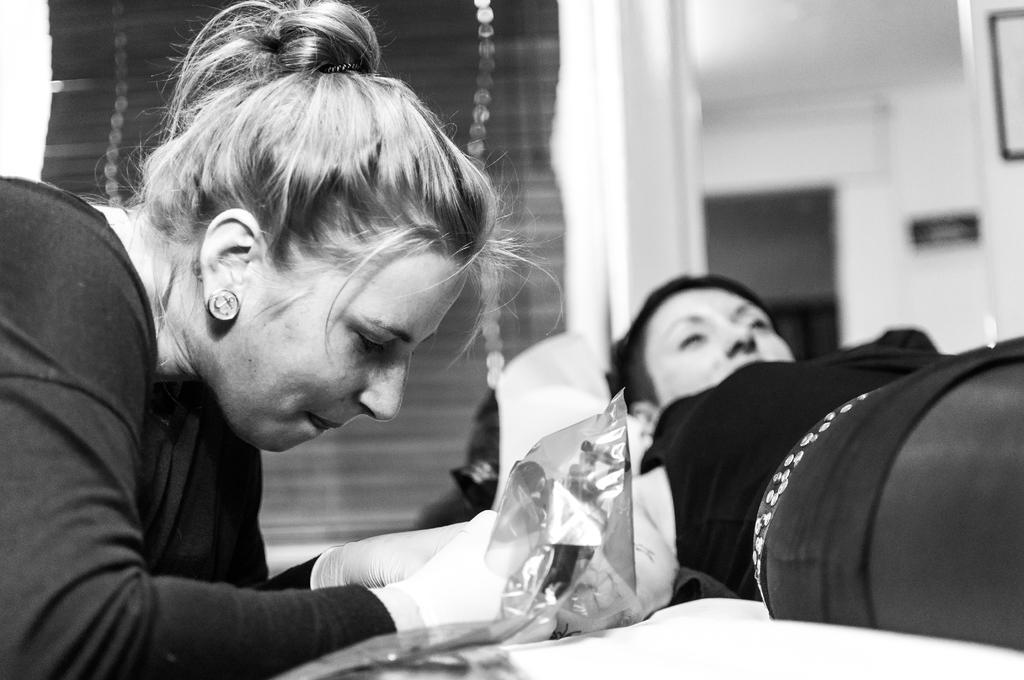How would you summarize this image in a sentence or two? On the right side of the image we can see a person lying on the bed. On the left there is a lady holding an object. In the background there is a door, wall and we can see blinds. 